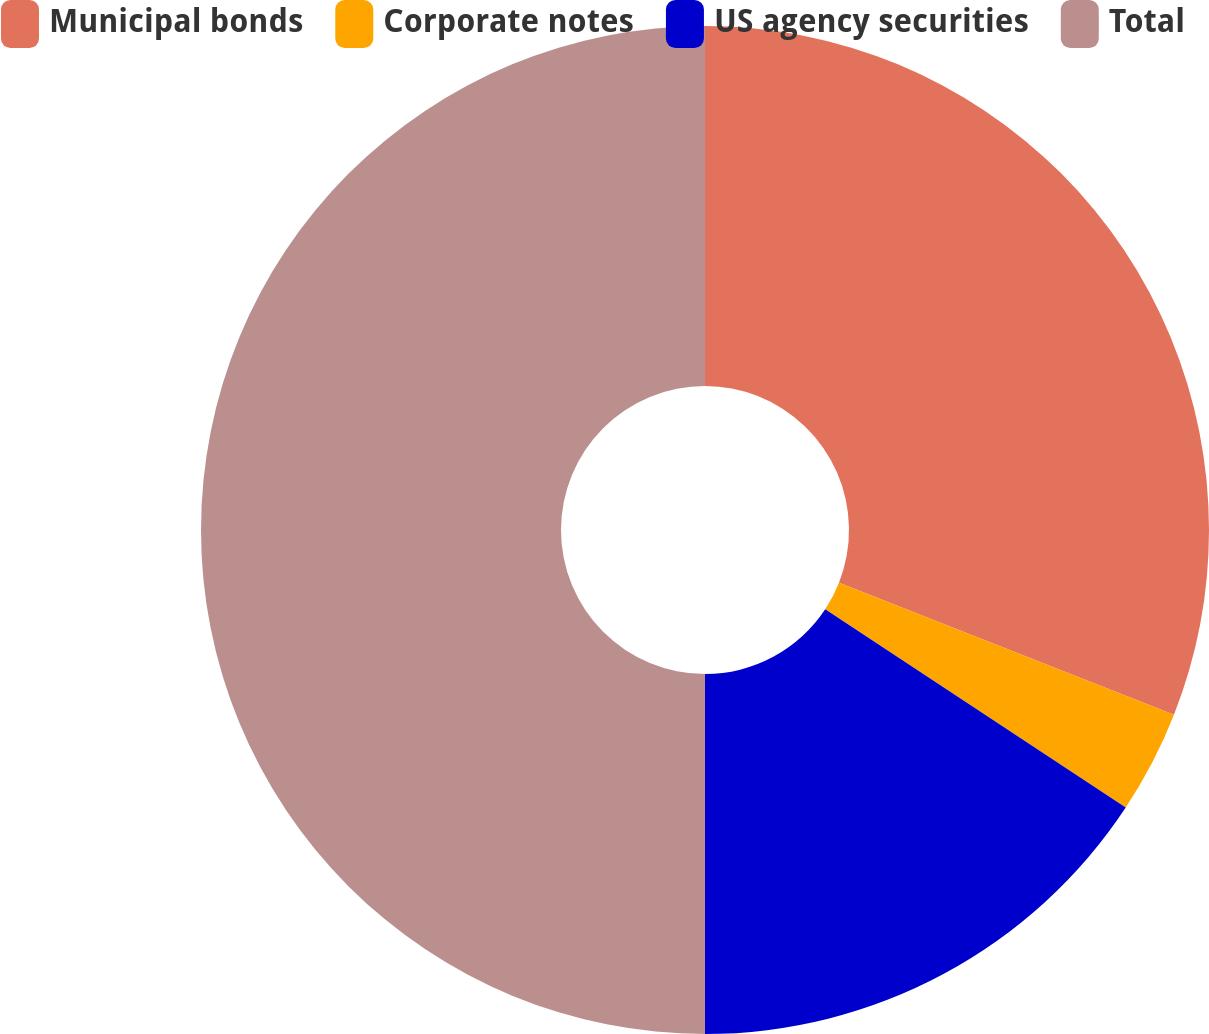<chart> <loc_0><loc_0><loc_500><loc_500><pie_chart><fcel>Municipal bonds<fcel>Corporate notes<fcel>US agency securities<fcel>Total<nl><fcel>30.97%<fcel>3.31%<fcel>15.72%<fcel>50.0%<nl></chart> 